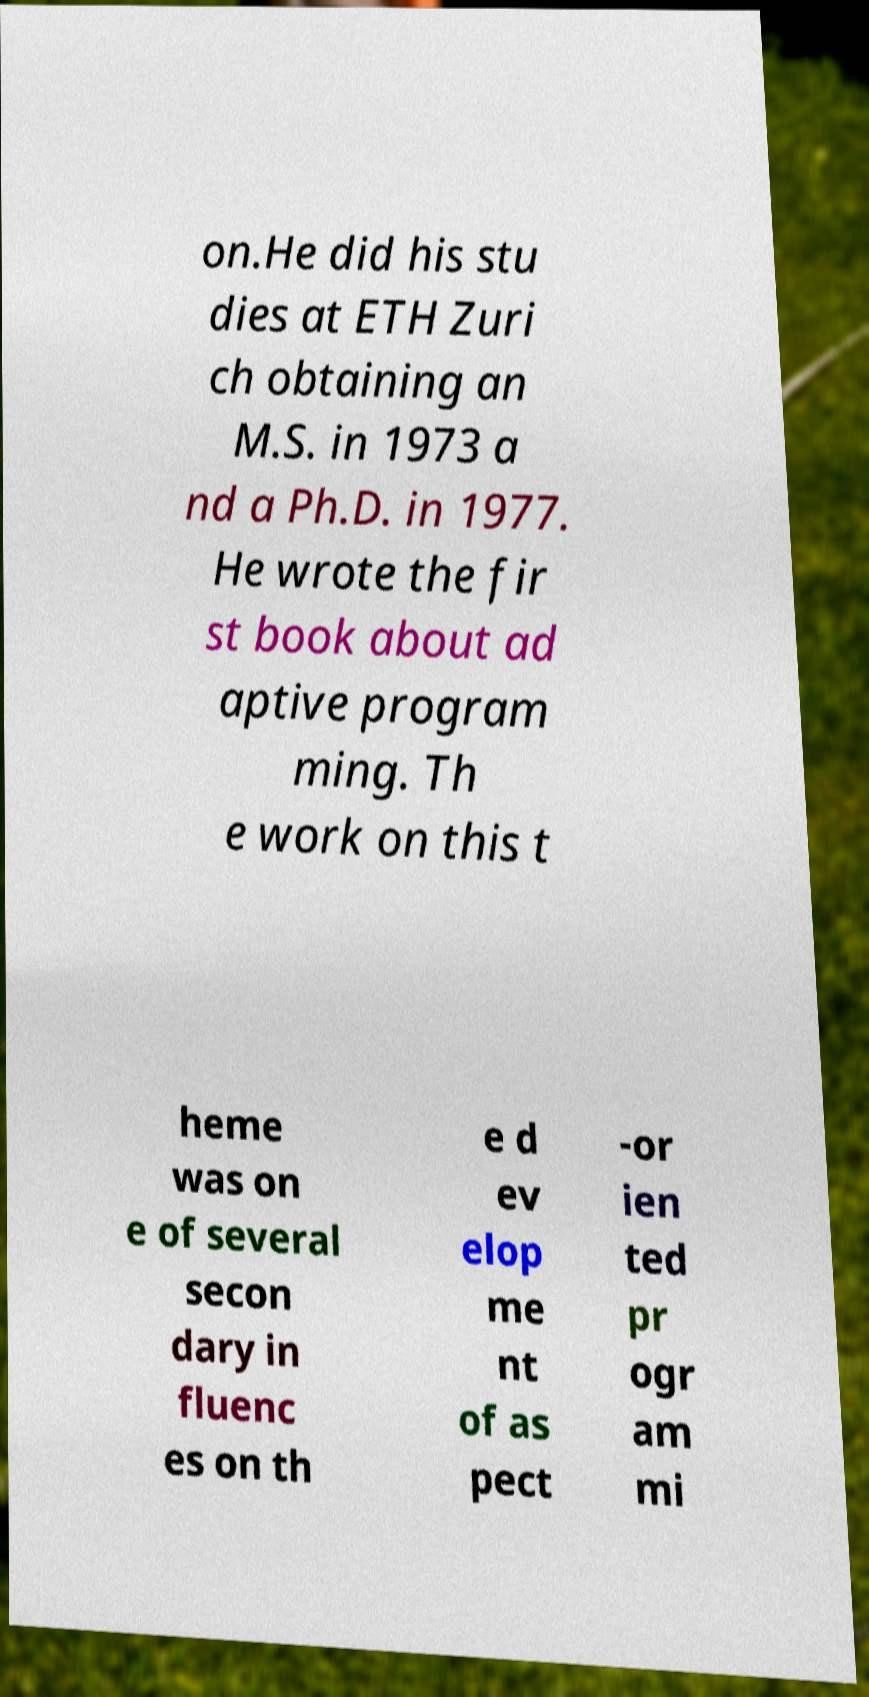Can you accurately transcribe the text from the provided image for me? on.He did his stu dies at ETH Zuri ch obtaining an M.S. in 1973 a nd a Ph.D. in 1977. He wrote the fir st book about ad aptive program ming. Th e work on this t heme was on e of several secon dary in fluenc es on th e d ev elop me nt of as pect -or ien ted pr ogr am mi 